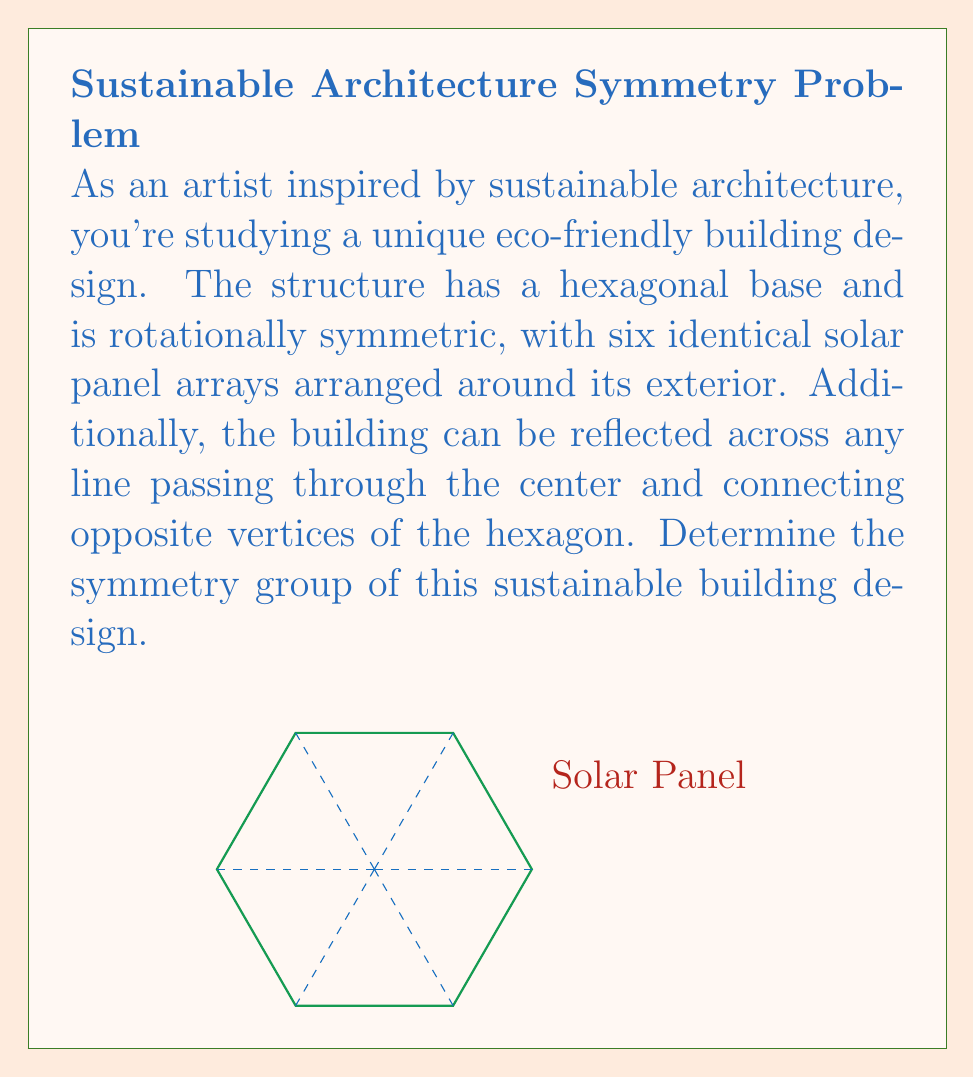Help me with this question. To determine the symmetry group of this sustainable building design, we need to identify all the symmetry operations that leave the structure unchanged. Let's approach this step-by-step:

1) Rotational symmetry:
   The building has 6-fold rotational symmetry, meaning it remains unchanged after rotations of $\frac{2\pi}{6}, \frac{4\pi}{6}, \frac{6\pi}{6}, \frac{8\pi}{6}, \frac{10\pi}{6}$, and $2\pi$ radians.

2) Reflection symmetry:
   The building has 6 lines of reflection symmetry, each passing through the center and connecting opposite vertices of the hexagon.

3) Identity:
   The identity operation (doing nothing) is always a symmetry.

These symmetries form a group under composition. This group is isomorphic to the dihedral group $D_6$, which is the group of symmetries of a regular hexagon.

The order of this group is:
$$|D_6| = 2n = 2(6) = 12$$

Where $n$ is the number of sides of the polygon (in this case, 6).

The elements of $D_6$ can be represented as:
- 6 rotations: $r^0, r^1, r^2, r^3, r^4, r^5$ (where $r$ represents a rotation by $\frac{2\pi}{6}$)
- 6 reflections: $s_1, s_2, s_3, s_4, s_5, s_6$

The group operation table for $D_6$ would show how these elements combine under composition.

Therefore, the symmetry group of this sustainable building design is the dihedral group $D_6$.
Answer: $D_6$ 